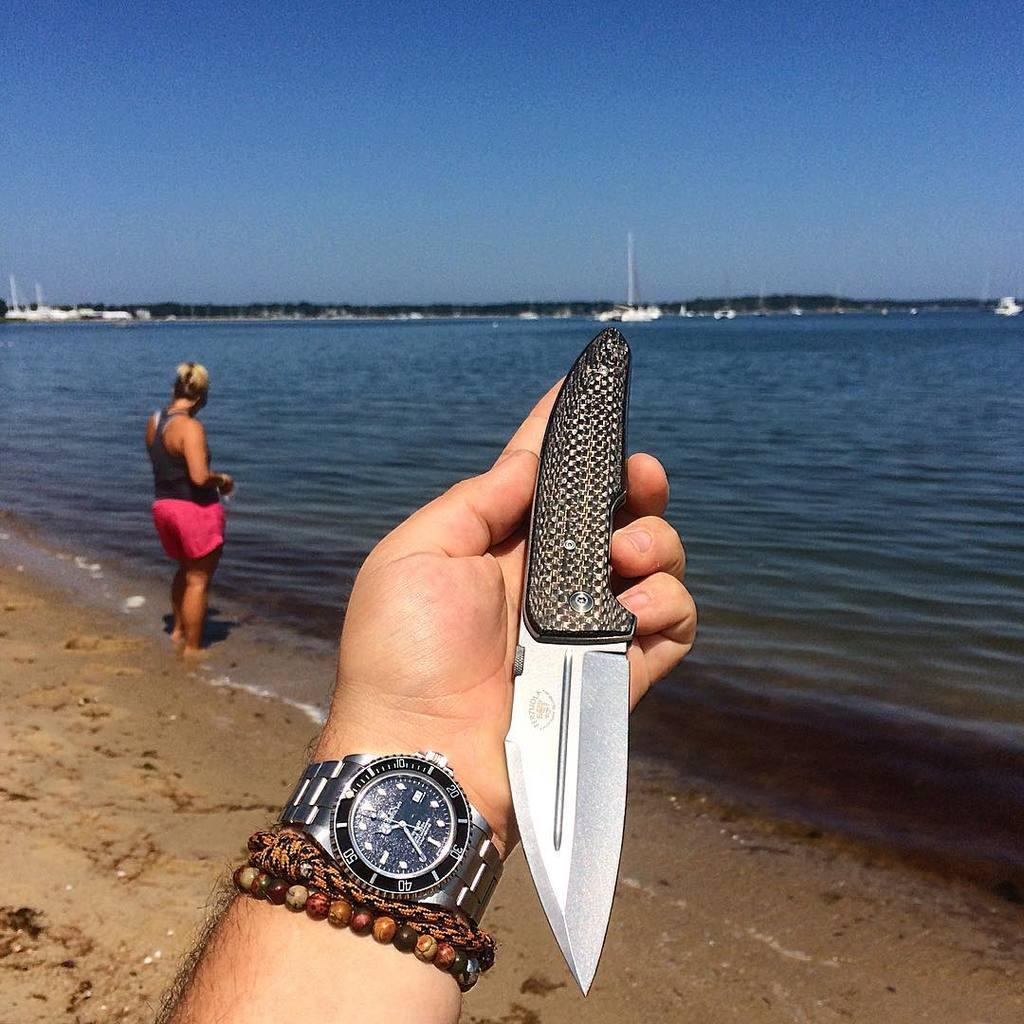<image>
Relay a brief, clear account of the picture shown. The time is 10:35 on a man's watch and he holds a knife in his hand on a beach. 